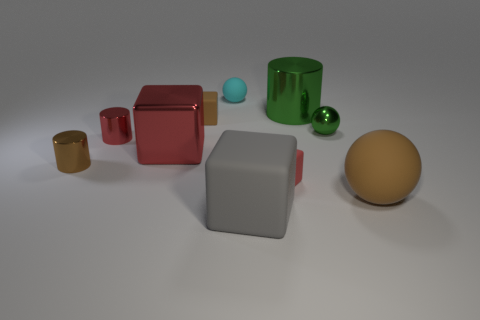Subtract all matte balls. How many balls are left? 1 Subtract all brown cylinders. How many cylinders are left? 2 Subtract 1 cylinders. How many cylinders are left? 2 Subtract all cylinders. How many objects are left? 7 Subtract all red cylinders. Subtract all blue cubes. How many cylinders are left? 2 Subtract all green balls. How many red cylinders are left? 1 Subtract all brown metal balls. Subtract all green cylinders. How many objects are left? 9 Add 7 large brown objects. How many large brown objects are left? 8 Add 3 green metal blocks. How many green metal blocks exist? 3 Subtract 0 red spheres. How many objects are left? 10 